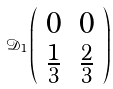<formula> <loc_0><loc_0><loc_500><loc_500>\mathcal { D } _ { 1 } \left ( \begin{array} { c c } { 0 } & { 0 } \\ { { \frac { 1 } { 3 } } } & { { \frac { 2 } { 3 } } } \end{array} \right )</formula> 